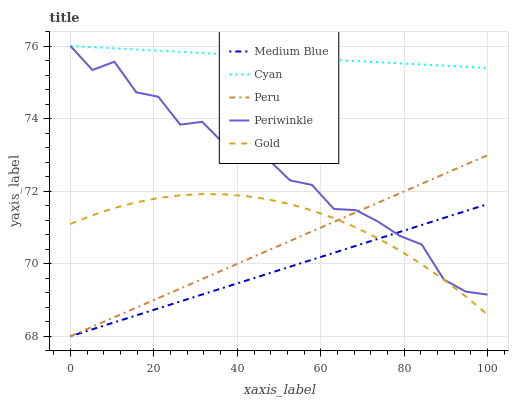Does Medium Blue have the minimum area under the curve?
Answer yes or no. Yes. Does Cyan have the maximum area under the curve?
Answer yes or no. Yes. Does Periwinkle have the minimum area under the curve?
Answer yes or no. No. Does Periwinkle have the maximum area under the curve?
Answer yes or no. No. Is Cyan the smoothest?
Answer yes or no. Yes. Is Periwinkle the roughest?
Answer yes or no. Yes. Is Medium Blue the smoothest?
Answer yes or no. No. Is Medium Blue the roughest?
Answer yes or no. No. Does Medium Blue have the lowest value?
Answer yes or no. Yes. Does Periwinkle have the lowest value?
Answer yes or no. No. Does Periwinkle have the highest value?
Answer yes or no. Yes. Does Medium Blue have the highest value?
Answer yes or no. No. Is Medium Blue less than Cyan?
Answer yes or no. Yes. Is Cyan greater than Medium Blue?
Answer yes or no. Yes. Does Periwinkle intersect Medium Blue?
Answer yes or no. Yes. Is Periwinkle less than Medium Blue?
Answer yes or no. No. Is Periwinkle greater than Medium Blue?
Answer yes or no. No. Does Medium Blue intersect Cyan?
Answer yes or no. No. 